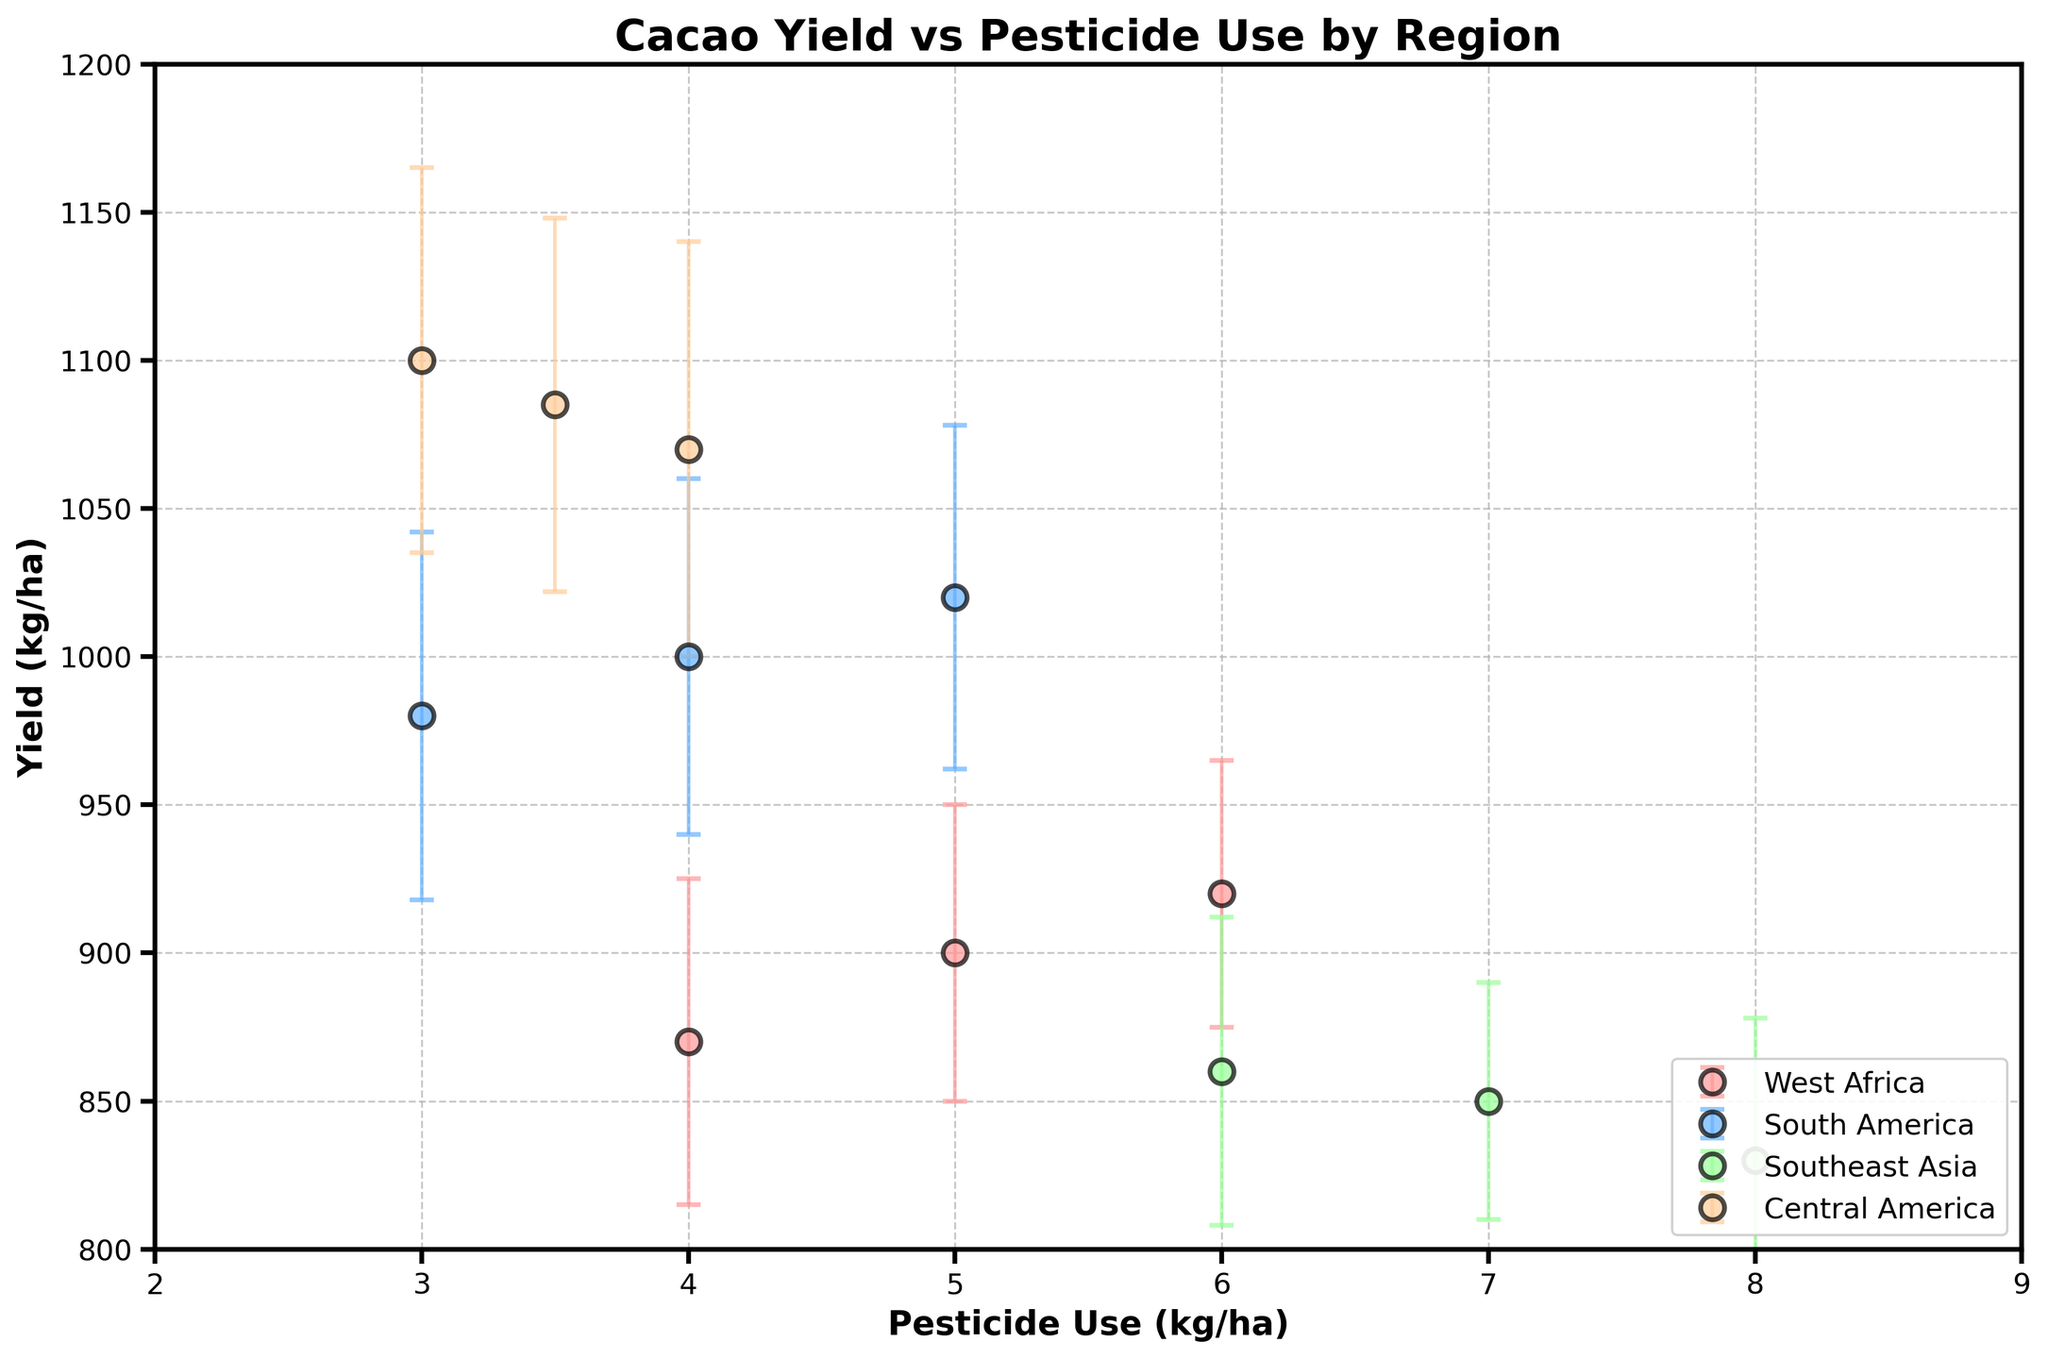How many regions are represented in the plot? There are four different regions depicted in the plot, as indicated by the four distinct colors in the legend: West Africa, South America, Southeast Asia, and Central America.
Answer: 4 What is the title of the plot? The title of the plot is clearly shown at the top and reads "Cacao Yield vs Pesticide Use by Region".
Answer: Cacao Yield vs Pesticide Use by Region Which region has the highest average yield? To find the region with the highest average yield, we need to look at the vertical placement of the data points for each region and check their central tendency. Central America's data points are higher than those of other regions, indicating the highest average yield.
Answer: Central America What is the range of pesticide use values in the plot? The x-axis shows the range of pesticide use values, which spans from 3 kg/ha to 8 kg/ha.
Answer: 3 to 8 kg/ha Which region shows the highest variability in yield? To determine the region with the highest yield variability, we look at the error bars' length. Central America has the longest error bars, indicating the highest variability.
Answer: Central America What average yield does South America achieve when 5 kg/ha of pesticide is used? Locate the data point for South America at 5 kg/ha of pesticide use along the x-axis, then look at the corresponding value on the y-axis, which is around 1020 kg/ha.
Answer: 1020 kg/ha Is there any overlap in yield among regions when pesticide use is at 4 kg/ha? At 4 kg/ha of pesticide use, we compare the vertical spread of data points. West Africa, South America, and Central America all have data points around this level, indicating overlap.
Answer: Yes Which region has data points closest to each other in terms of yield? The region whose data points are closely clustered in terms of yield values can be determined by checking the spread along the y-axis. Southeast Asia's yield points are closer to each other than points in other regions.
Answer: Southeast Asia How does the average incidence of disease compare between West Africa and Southeast Asia? Although disease incidence isn't directly plotted, regions' incidence percentages are averaged by observing the general trend for each region: 20% (West Africa) vs. 25% (Southeast Asia).
Answer: West Africa: 20%, Southeast Asia: 25% What is the common feature of all error bars in the plot? All error bars in the plot are symmetrical and indicate standard deviations of yields, they also have cap lines at both ends.
Answer: Symmetrical, with cap lines indicating standard deviations 